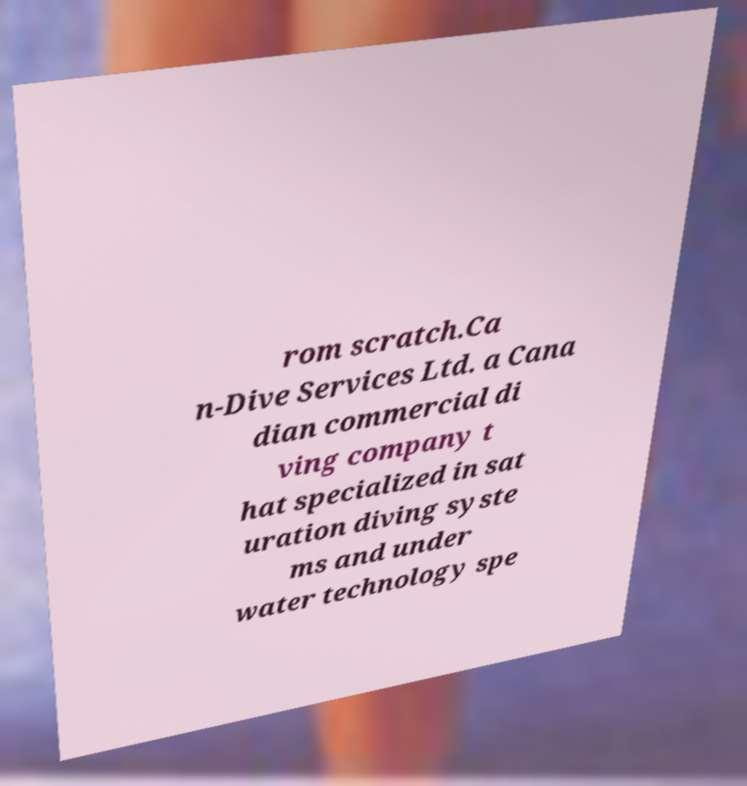I need the written content from this picture converted into text. Can you do that? rom scratch.Ca n-Dive Services Ltd. a Cana dian commercial di ving company t hat specialized in sat uration diving syste ms and under water technology spe 